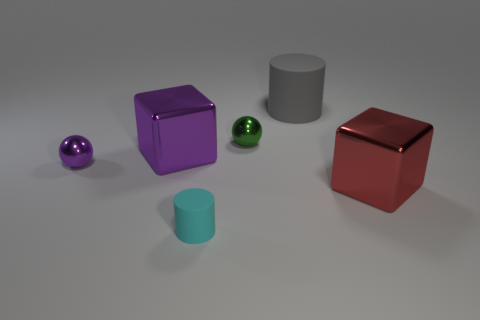There is another matte object that is the same shape as the small rubber thing; what color is it?
Give a very brief answer. Gray. How many small cyan cylinders have the same material as the gray cylinder?
Make the answer very short. 1. There is a cyan thing; how many cyan matte objects are on the left side of it?
Offer a very short reply. 0. The gray matte cylinder is what size?
Your answer should be very brief. Large. There is a block that is the same size as the red thing; what color is it?
Give a very brief answer. Purple. What material is the tiny cyan cylinder?
Offer a terse response. Rubber. What number of large red blocks are there?
Offer a very short reply. 1. There is a large cube that is behind the tiny purple ball; is it the same color as the tiny sphere to the left of the purple metallic cube?
Provide a succinct answer. Yes. What is the color of the big metallic thing behind the red shiny object?
Ensure brevity in your answer.  Purple. Is the material of the cylinder to the right of the small rubber cylinder the same as the red block?
Your answer should be compact. No. 